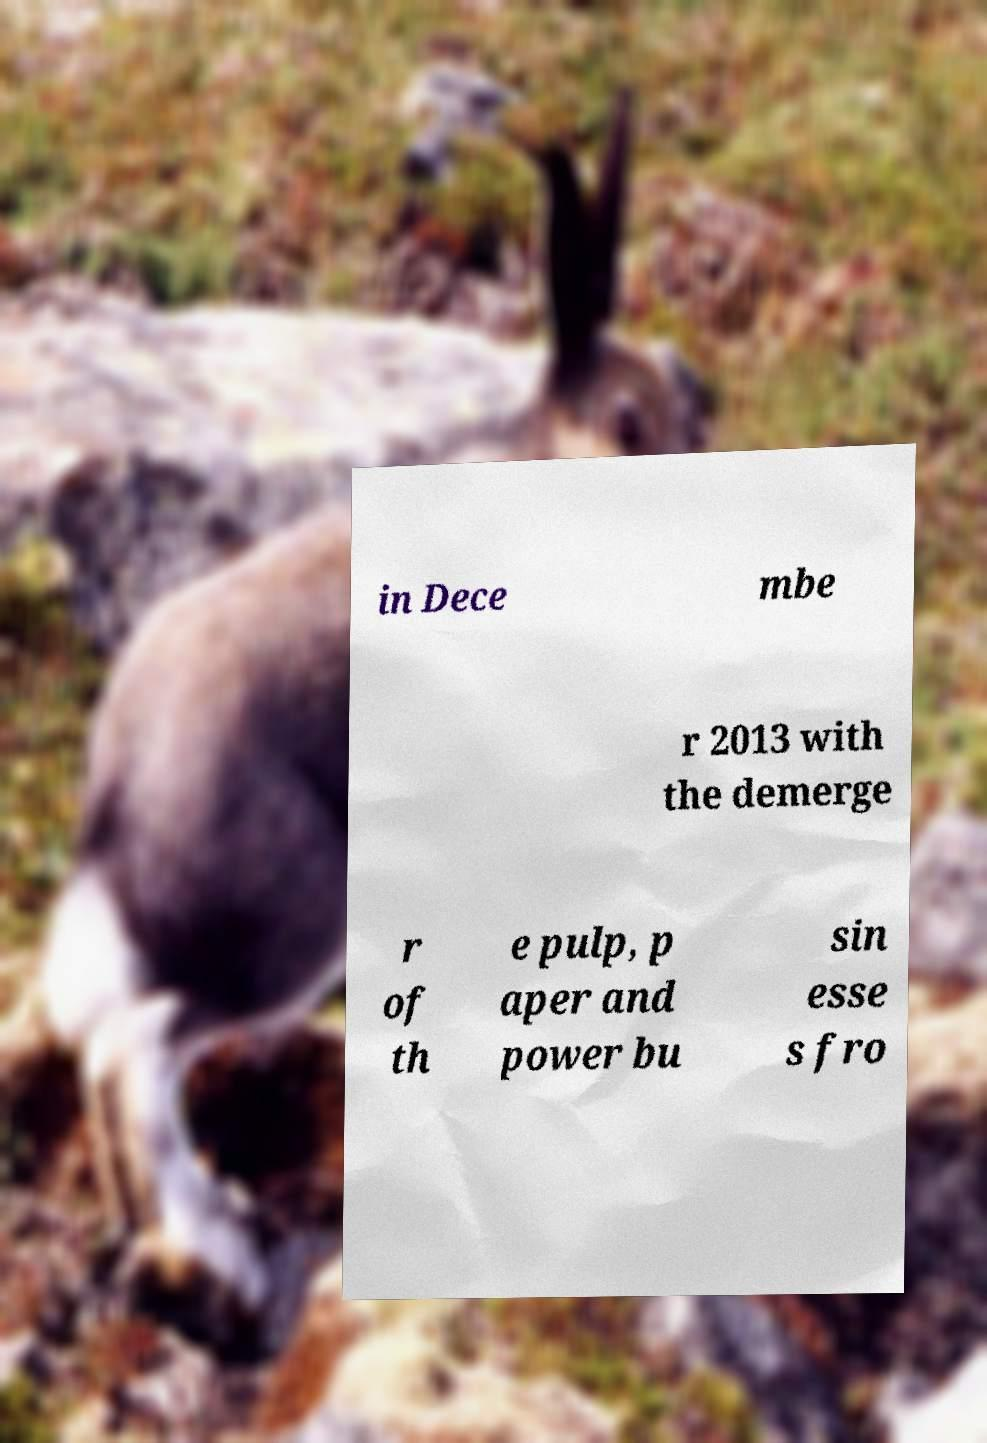I need the written content from this picture converted into text. Can you do that? in Dece mbe r 2013 with the demerge r of th e pulp, p aper and power bu sin esse s fro 